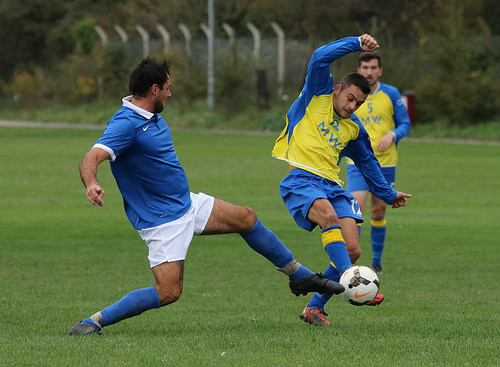<image>
Is the pole behind the fence? No. The pole is not behind the fence. From this viewpoint, the pole appears to be positioned elsewhere in the scene. 